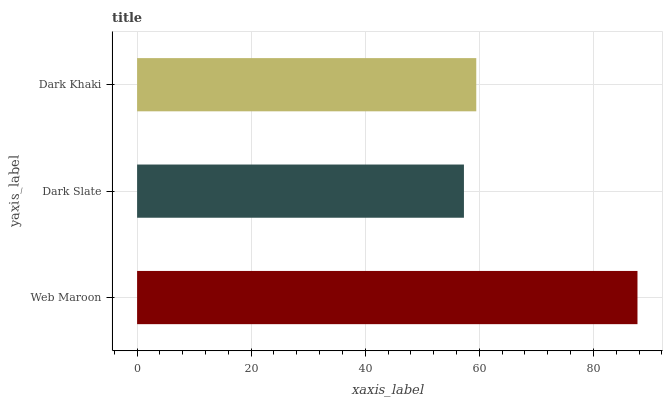Is Dark Slate the minimum?
Answer yes or no. Yes. Is Web Maroon the maximum?
Answer yes or no. Yes. Is Dark Khaki the minimum?
Answer yes or no. No. Is Dark Khaki the maximum?
Answer yes or no. No. Is Dark Khaki greater than Dark Slate?
Answer yes or no. Yes. Is Dark Slate less than Dark Khaki?
Answer yes or no. Yes. Is Dark Slate greater than Dark Khaki?
Answer yes or no. No. Is Dark Khaki less than Dark Slate?
Answer yes or no. No. Is Dark Khaki the high median?
Answer yes or no. Yes. Is Dark Khaki the low median?
Answer yes or no. Yes. Is Web Maroon the high median?
Answer yes or no. No. Is Web Maroon the low median?
Answer yes or no. No. 